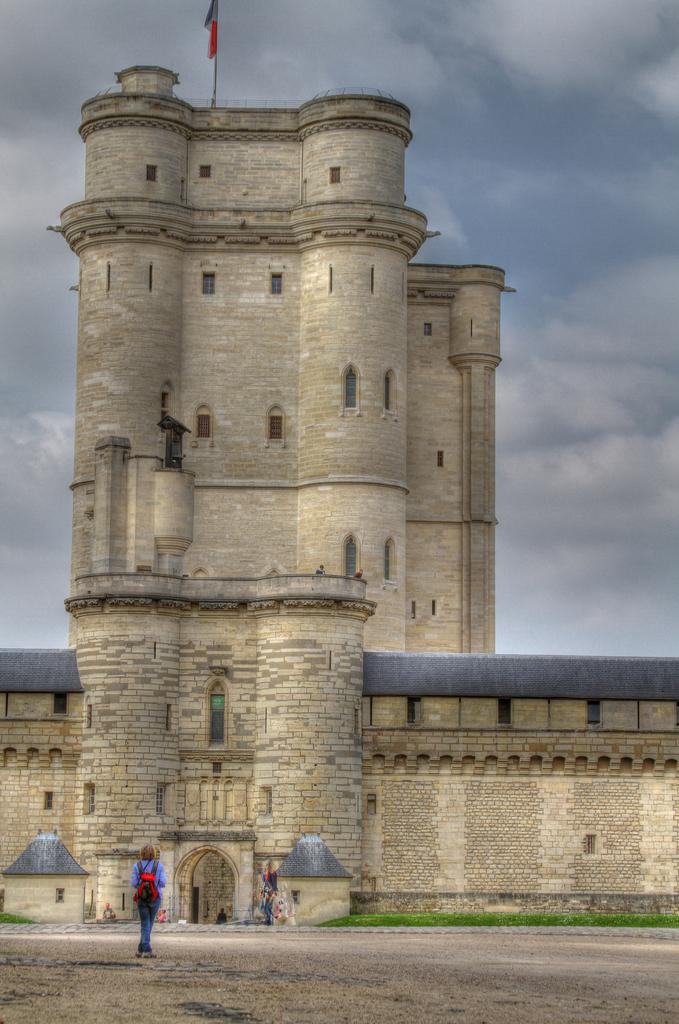What is the main subject in the center of the image? There is a flag in the center of the image. Where is the flag located? The flag is on a fort. What can be seen in the background of the image? There are clouds in the sky in the background. What is happening at the bottom of the image? There are people on the ground at the bottom of the image. What type of cracker is being played by the people at the bottom of the image? There is no cracker being played in the image; the people are simply standing on the ground. What kind of music is being performed by the sheep in the image? There are no sheep or music present in the image. 